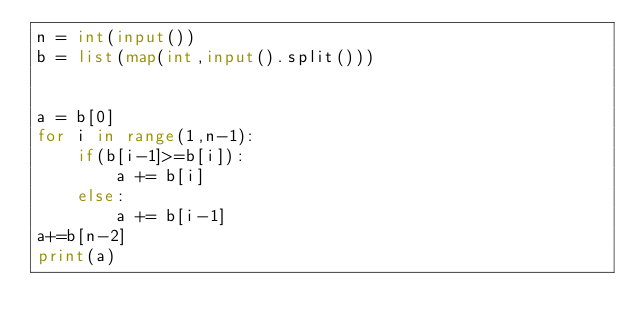Convert code to text. <code><loc_0><loc_0><loc_500><loc_500><_Python_>n = int(input())
b = list(map(int,input().split()))


a = b[0]
for i in range(1,n-1):
    if(b[i-1]>=b[i]):
        a += b[i]
    else:
        a += b[i-1]
a+=b[n-2]
print(a)</code> 